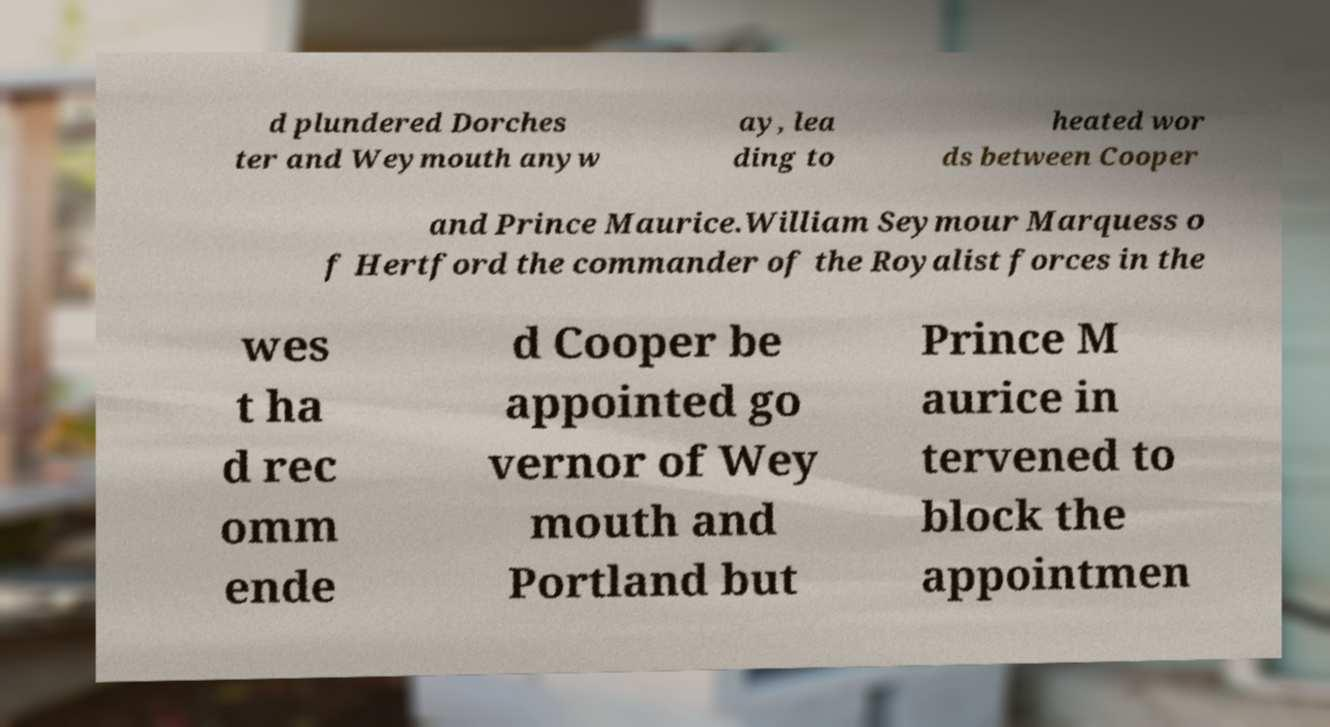Can you accurately transcribe the text from the provided image for me? d plundered Dorches ter and Weymouth anyw ay, lea ding to heated wor ds between Cooper and Prince Maurice.William Seymour Marquess o f Hertford the commander of the Royalist forces in the wes t ha d rec omm ende d Cooper be appointed go vernor of Wey mouth and Portland but Prince M aurice in tervened to block the appointmen 